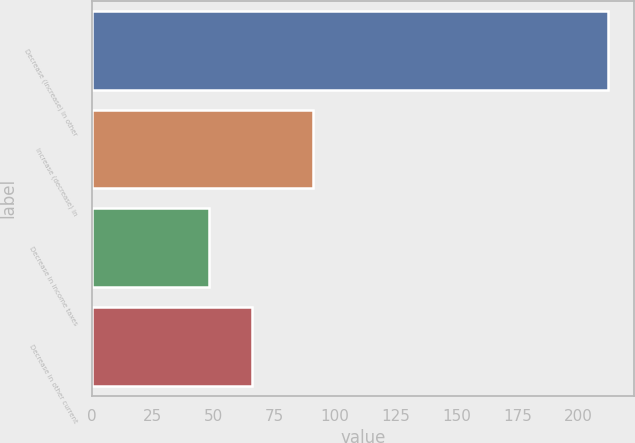<chart> <loc_0><loc_0><loc_500><loc_500><bar_chart><fcel>Decrease (increase) in other<fcel>Increase (decrease) in<fcel>Decrease in income taxes<fcel>Decrease in other current<nl><fcel>212<fcel>91<fcel>48<fcel>66<nl></chart> 